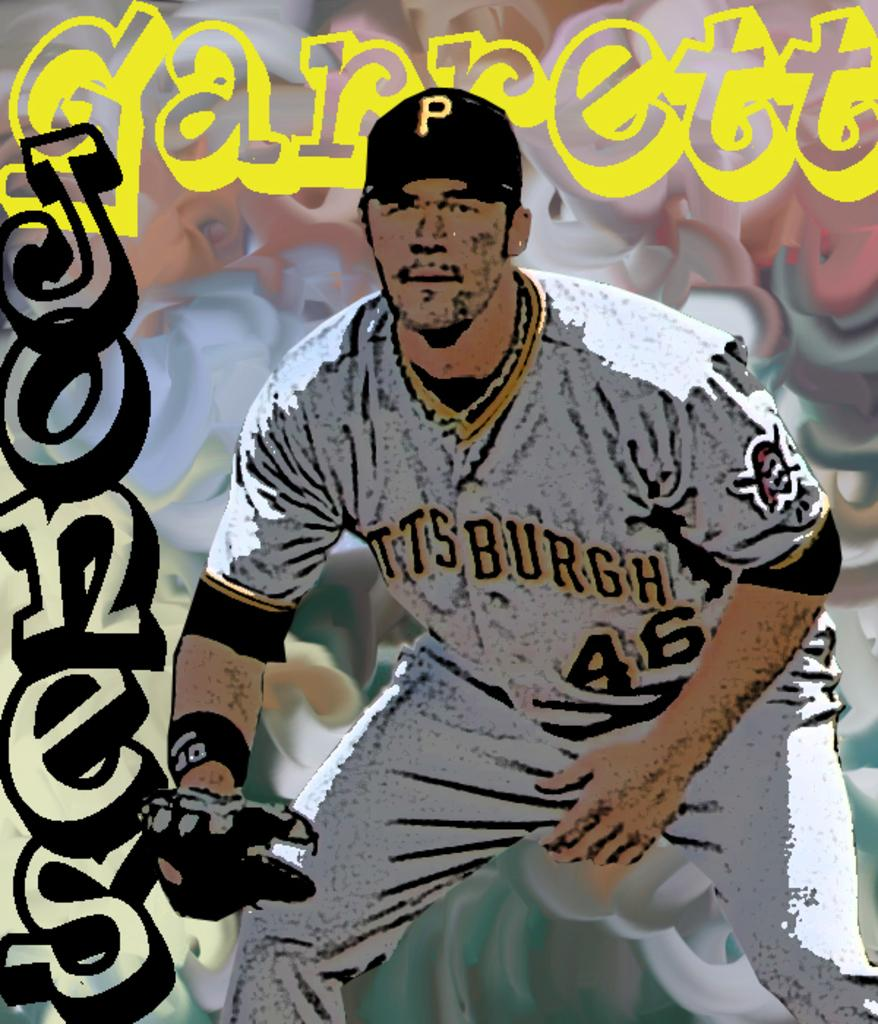<image>
Relay a brief, clear account of the picture shown. A simulated drawing of a Pittsburgh baseball player. 